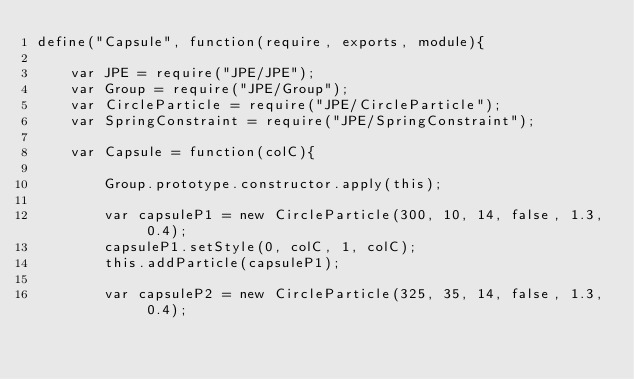Convert code to text. <code><loc_0><loc_0><loc_500><loc_500><_JavaScript_>define("Capsule", function(require, exports, module){
    
    var JPE = require("JPE/JPE");
    var Group = require("JPE/Group");
    var CircleParticle = require("JPE/CircleParticle");
    var SpringConstraint = require("JPE/SpringConstraint");

    var Capsule = function(colC){

        Group.prototype.constructor.apply(this);

		var capsuleP1 = new CircleParticle(300, 10, 14, false, 1.3, 0.4);
		capsuleP1.setStyle(0, colC, 1, colC);
		this.addParticle(capsuleP1);
		
		var capsuleP2 = new CircleParticle(325, 35, 14, false, 1.3, 0.4);</code> 